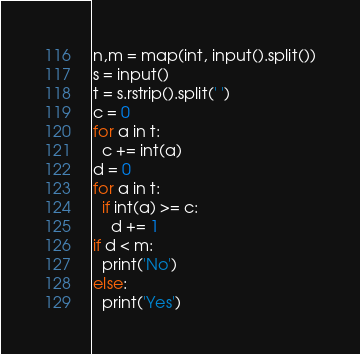Convert code to text. <code><loc_0><loc_0><loc_500><loc_500><_Python_>n,m = map(int, input().split())
s = input()
t = s.rstrip().split(' ')
c = 0
for a in t:
  c += int(a)
d = 0
for a in t:
  if int(a) >= c:
    d += 1
if d < m:
  print('No')
else:
  print('Yes')</code> 